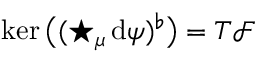<formula> <loc_0><loc_0><loc_500><loc_500>\ker \left ( ( ^ { * } _ { \mu } \, d \psi ) ^ { \flat } \right ) = T { \mathcal { F } }</formula> 